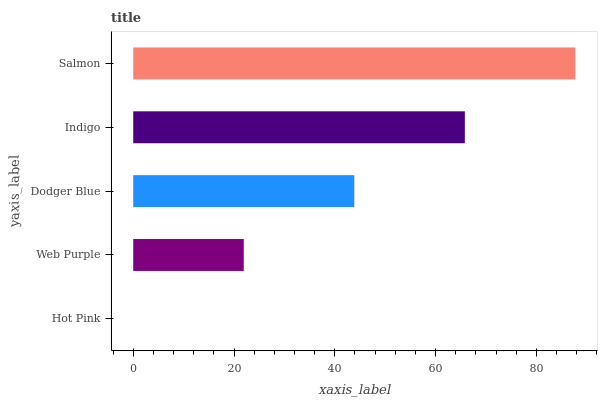Is Hot Pink the minimum?
Answer yes or no. Yes. Is Salmon the maximum?
Answer yes or no. Yes. Is Web Purple the minimum?
Answer yes or no. No. Is Web Purple the maximum?
Answer yes or no. No. Is Web Purple greater than Hot Pink?
Answer yes or no. Yes. Is Hot Pink less than Web Purple?
Answer yes or no. Yes. Is Hot Pink greater than Web Purple?
Answer yes or no. No. Is Web Purple less than Hot Pink?
Answer yes or no. No. Is Dodger Blue the high median?
Answer yes or no. Yes. Is Dodger Blue the low median?
Answer yes or no. Yes. Is Hot Pink the high median?
Answer yes or no. No. Is Hot Pink the low median?
Answer yes or no. No. 